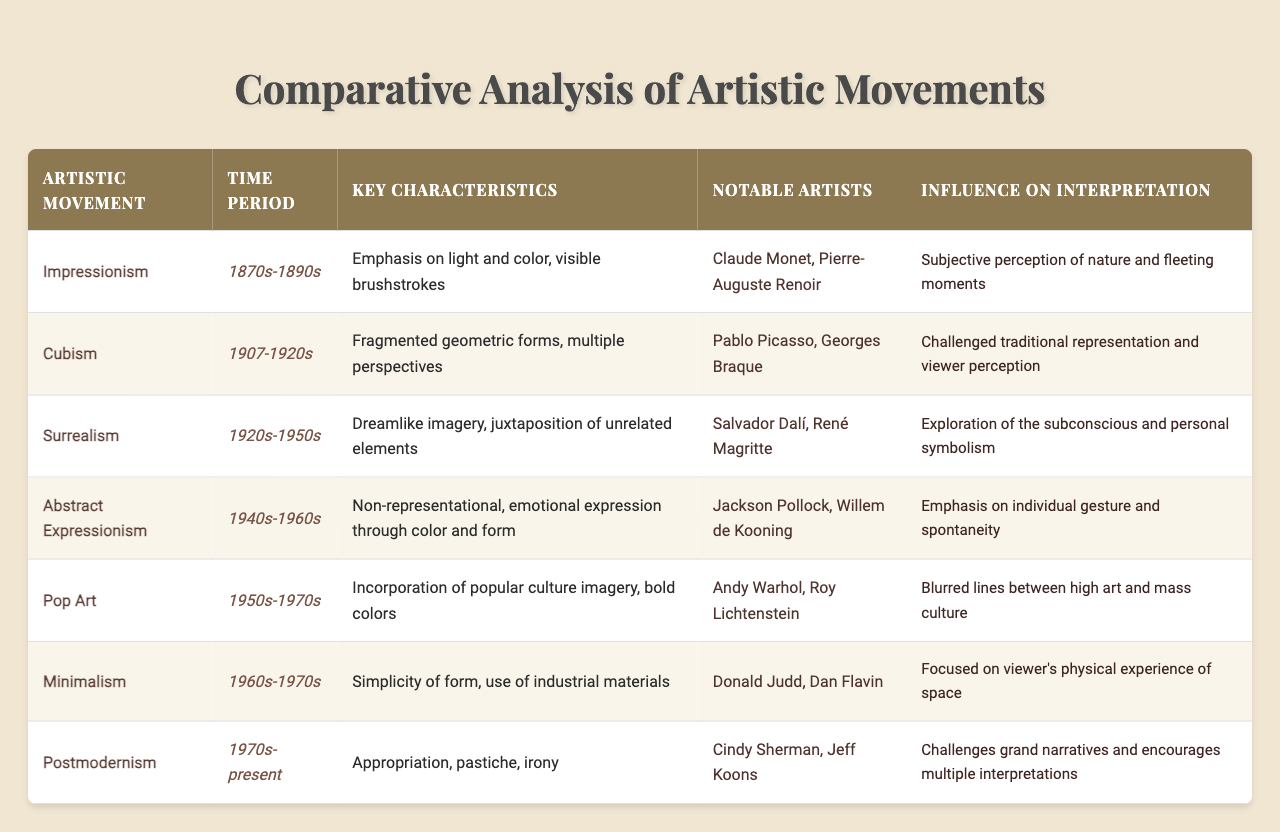What time period did Impressionism cover? The time period for Impressionism as mentioned in the table is from the 1870s to the 1890s.
Answer: 1870s-1890s Which movement is associated with Pablo Picasso? The table states that Pablo Picasso is a notable artist associated with Cubism.
Answer: Cubism Does Minimalism focus on complex forms? According to the table, Minimalism features simplicity of form, which implies it does not focus on complex forms.
Answer: No Which artistic movement emphasizes individual gesture and spontaneity? The table indicates that Abstract Expressionism emphasizes individual gesture and spontaneity.
Answer: Abstract Expressionism What are the key characteristics of Pop Art? The key characteristics listed for Pop Art in the table include the incorporation of popular culture imagery and bold colors.
Answer: Incorporation of popular culture imagery, bold colors How do the influences on interpretation differ between Surrealism and Cubism? Surrealism emphasizes exploration of the subconscious and personal symbolism, while Cubism challenges traditional representation and viewer perception, highlighting different aspects of interpretation.
Answer: They emphasize different aspects of interpretation List two notable artists from the Abstract Expressionism movement. The table mentions Jackson Pollock and Willem de Kooning as notable artists from the Abstract Expressionism movement.
Answer: Jackson Pollock, Willem de Kooning What is the primary influence of Postmodernism on art interpretation? According to the table, Postmodernism challenges grand narratives and encourages multiple interpretations in art.
Answer: Challenges grand narratives and encourages multiple interpretations How many movements listed were prominent in the 1970s? The table shows that both Pop Art and Postmodernism were prominent in the 1970s, making a total of two movements in that decade.
Answer: Two movements Compare the key characteristics of Impressionism and Abstract Expressionism. Impressionism focuses on light and color with visible brushstrokes, while Abstract Expressionism is non-representational and emphasizes emotional expression through color and form, highlighting a shift in artistic emphasis.
Answer: They present different artistic emphases 